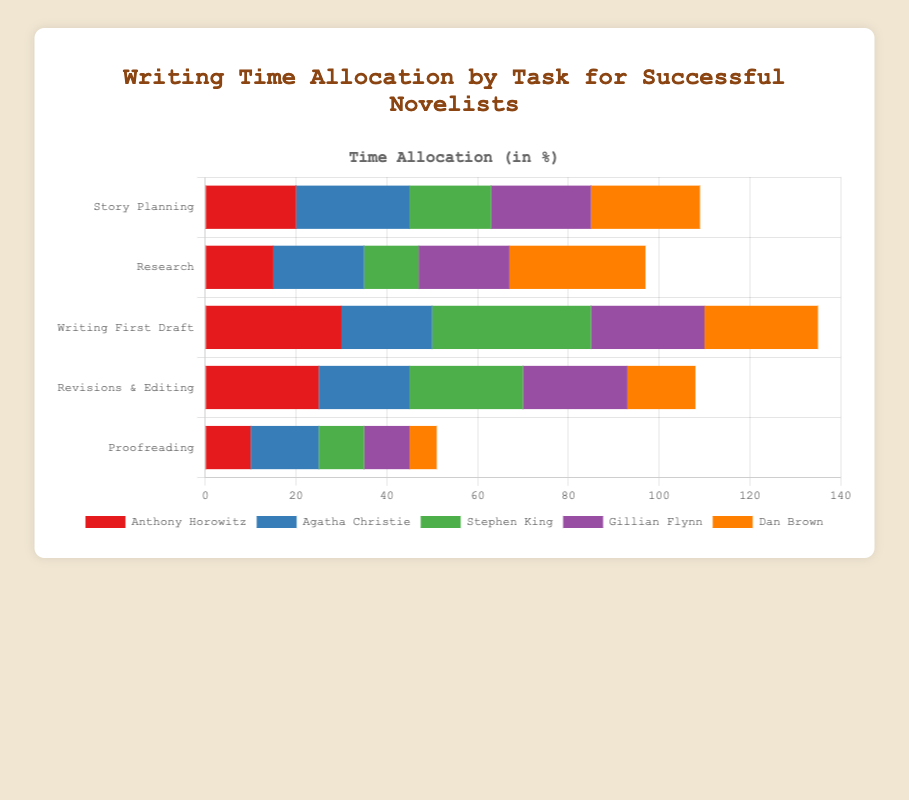What's the total writing time allocated by Stephen King across all tasks? Sum the writing time percentages for Stephen King: 18 (Story Planning) + 12 (Research) + 35 (Writing First Draft) + 25 (Revisions & Editing) + 10 (Proofreading) = 100.
Answer: 100 Who spends more time on Research, Anthony Horowitz or Gillian Flynn? Compare the bars for Research between Anthony Horowitz and Gillian Flynn. Anthony Horowitz allocates 15%, while Gillian Flynn allocates 20%. Therefore, Gillian Flynn spends more time on Research.
Answer: Gillian Flynn What is the difference in time spent on "Writing First Draft" between the novelist who spends the most and the one who spends the least? Identify the highest and lowest values for "Writing First Draft": Stephen King spends 35%, and Agatha Christie spends 20%. The difference is 35 - 20 = 15.
Answer: 15 For which task does Anthony Horowitz allocate the maximum time, and what is that time? Look for the highest bar for Anthony Horowitz. The tallest bar corresponds to "Writing First Draft" with a value of 30%.
Answer: Writing First Draft, 30 Compare the total time allocation for "Story Planning" across all novelists. Who allocates the most and who the least time? Sum the percentages for "Story Planning": Anthony Horowitz (20) + Agatha Christie (25) + Stephen King (18) + Gillian Flynn (22) + Dan Brown (24). Agatha Christie allocates the most time (25%), and Stephen King allocates the least (18%).
Answer: Most: Agatha Christie, Least: Stephen King Which novelist spends the least time on Proofreading? Compare the bars for Proofreading across all novelists. Dan Brown has the smallest value, which is 6%.
Answer: Dan Brown What’s the average time spent on "Revisions & Editing" by Agatha Christie and Dan Brown? Calculate the average of the values: (20 + 15) / 2 = 17.5.
Answer: 17.5 How much more time does Dan Brown spend on Research compared to Story Planning? Compare the percentages for Dan Brown: Research (30%) and Story Planning (24%). The difference is 30 - 24 = 6.
Answer: 6 Who spends equal time on "Story Planning" and "Writing First Draft"? Compare the values for "Story Planning" and "Writing First Draft" for each novelist. Anthony Horowitz does not allocate equal time but comes close with 20% for "Story Planning" and 30% for "Writing First Draft". No novelist has equal values.
Answer: No one spends equal time Which two tasks does Agatha Christie spend an equal amount of time on and what is that time? Identify the bars of equal height for Agatha Christie. She spends 20% on both "Research" and "Revisions & Editing".
Answer: Research and Revisions & Editing, 20 